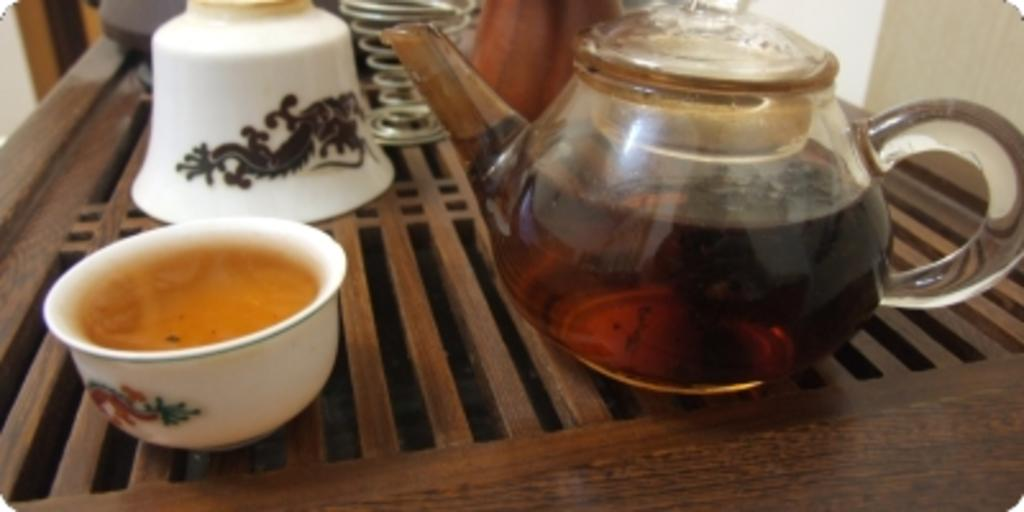What is in the bowl that is visible in the image? There is a bowl with a drink in the image. What other objects can be seen in the image? There is a kettle visible in the image. On what surface are the objects placed? The objects are placed on a wooden table. Where is the father sitting in the image? There is no father present in the image. 